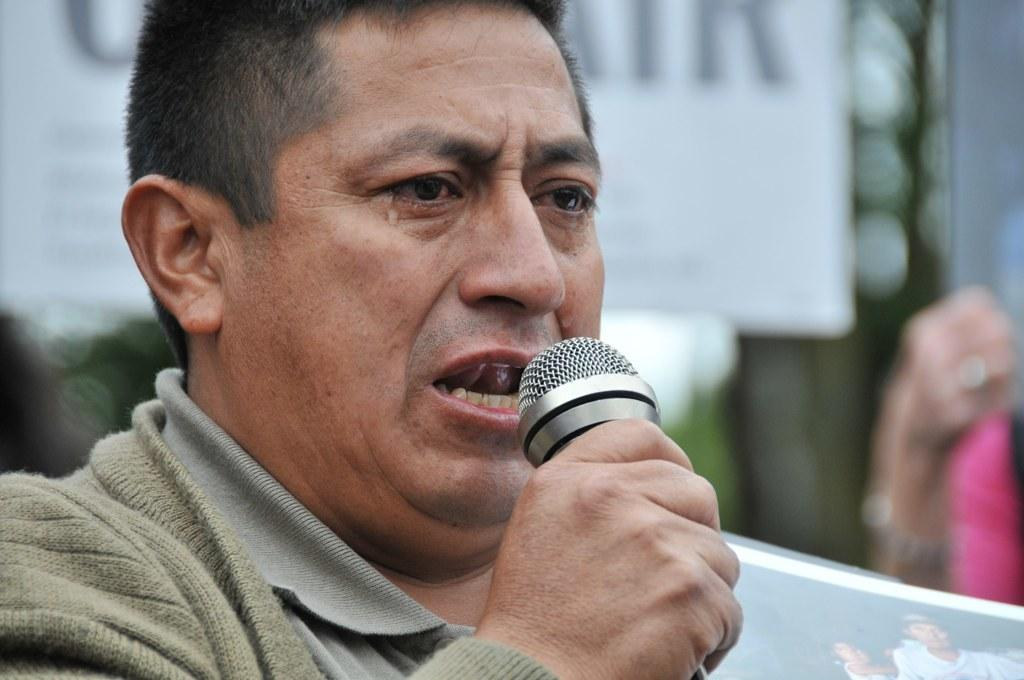What is present in the image? There is a person in the image. Can you describe what the person is wearing? The person is wearing a jacket. What is the person holding in his right hand? The person is holding a mic in his right hand. What type of brush is the person using to rub the paper in the image? There is no brush, paper, or rubbing activity present in the image. 